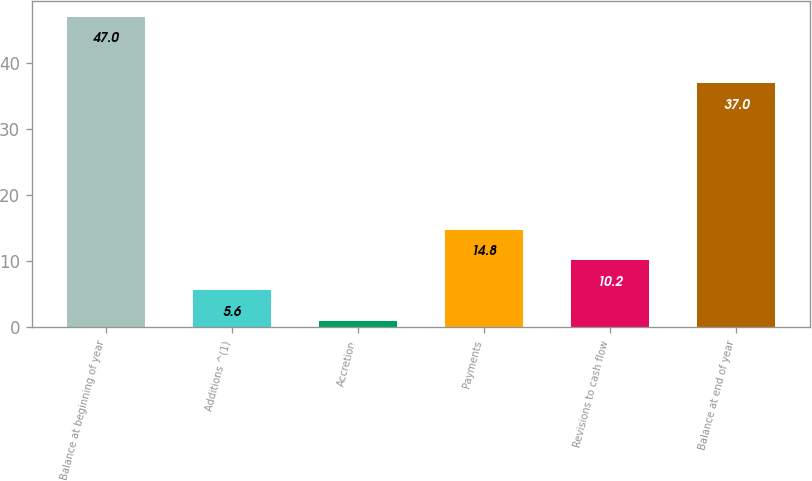Convert chart. <chart><loc_0><loc_0><loc_500><loc_500><bar_chart><fcel>Balance at beginning of year<fcel>Additions ^(1)<fcel>Accretion<fcel>Payments<fcel>Revisions to cash flow<fcel>Balance at end of year<nl><fcel>47<fcel>5.6<fcel>1<fcel>14.8<fcel>10.2<fcel>37<nl></chart> 